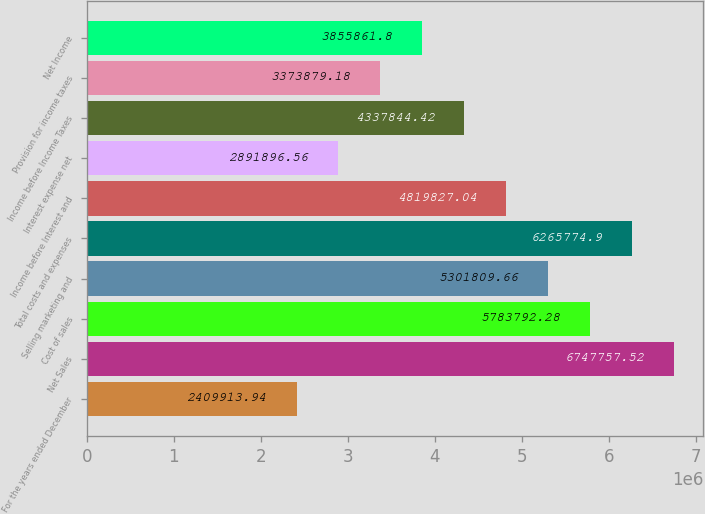<chart> <loc_0><loc_0><loc_500><loc_500><bar_chart><fcel>For the years ended December<fcel>Net Sales<fcel>Cost of sales<fcel>Selling marketing and<fcel>Total costs and expenses<fcel>Income before Interest and<fcel>Interest expense net<fcel>Income before Income Taxes<fcel>Provision for income taxes<fcel>Net Income<nl><fcel>2.40991e+06<fcel>6.74776e+06<fcel>5.78379e+06<fcel>5.30181e+06<fcel>6.26577e+06<fcel>4.81983e+06<fcel>2.8919e+06<fcel>4.33784e+06<fcel>3.37388e+06<fcel>3.85586e+06<nl></chart> 